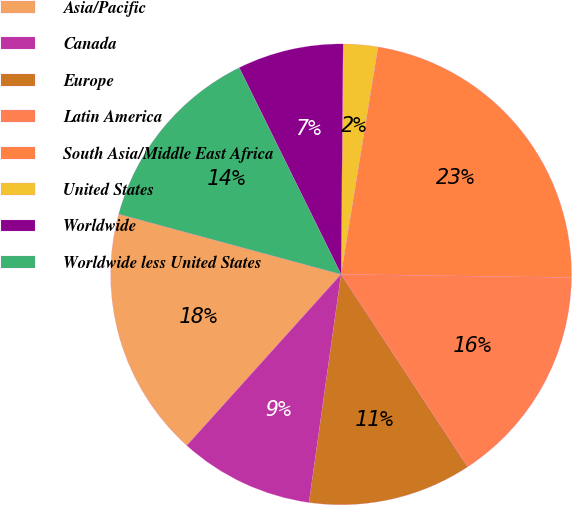Convert chart. <chart><loc_0><loc_0><loc_500><loc_500><pie_chart><fcel>Asia/Pacific<fcel>Canada<fcel>Europe<fcel>Latin America<fcel>South Asia/Middle East Africa<fcel>United States<fcel>Worldwide<fcel>Worldwide less United States<nl><fcel>17.54%<fcel>9.45%<fcel>11.48%<fcel>15.52%<fcel>22.65%<fcel>2.43%<fcel>7.43%<fcel>13.5%<nl></chart> 